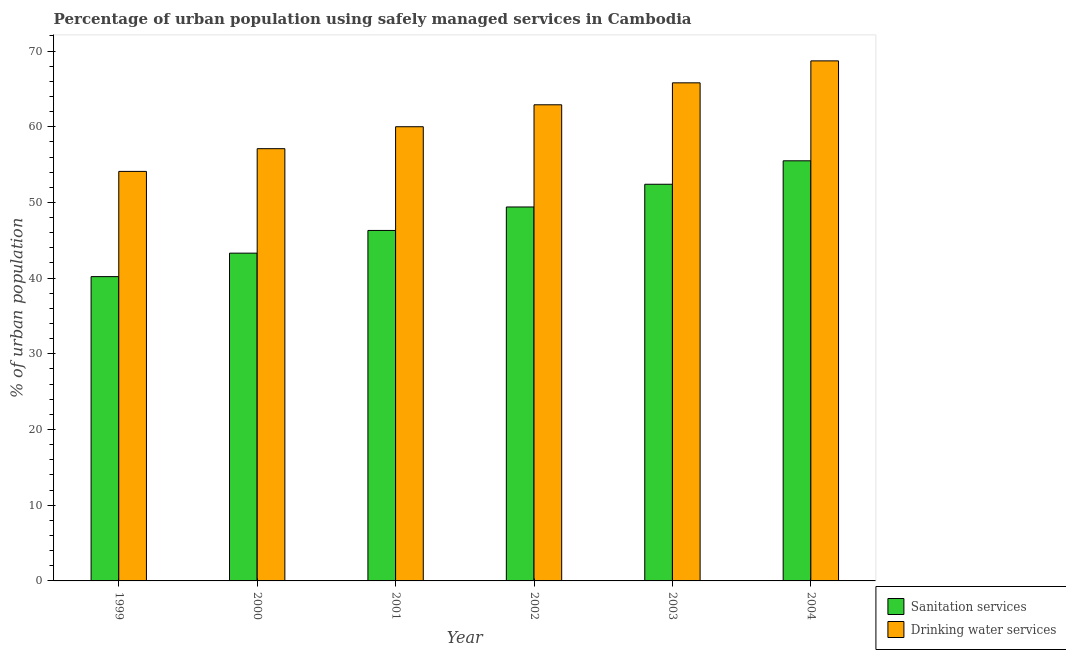How many different coloured bars are there?
Make the answer very short. 2. Are the number of bars per tick equal to the number of legend labels?
Provide a short and direct response. Yes. How many bars are there on the 4th tick from the right?
Your answer should be compact. 2. What is the label of the 4th group of bars from the left?
Your answer should be very brief. 2002. What is the percentage of urban population who used drinking water services in 2000?
Offer a very short reply. 57.1. Across all years, what is the maximum percentage of urban population who used drinking water services?
Provide a short and direct response. 68.7. Across all years, what is the minimum percentage of urban population who used drinking water services?
Keep it short and to the point. 54.1. In which year was the percentage of urban population who used drinking water services maximum?
Provide a short and direct response. 2004. In which year was the percentage of urban population who used drinking water services minimum?
Offer a very short reply. 1999. What is the total percentage of urban population who used drinking water services in the graph?
Make the answer very short. 368.6. What is the difference between the percentage of urban population who used sanitation services in 1999 and that in 2002?
Your answer should be very brief. -9.2. What is the difference between the percentage of urban population who used sanitation services in 2001 and the percentage of urban population who used drinking water services in 1999?
Your response must be concise. 6.1. What is the average percentage of urban population who used sanitation services per year?
Offer a very short reply. 47.85. What is the ratio of the percentage of urban population who used sanitation services in 1999 to that in 2000?
Offer a terse response. 0.93. Is the difference between the percentage of urban population who used sanitation services in 2002 and 2004 greater than the difference between the percentage of urban population who used drinking water services in 2002 and 2004?
Make the answer very short. No. What is the difference between the highest and the second highest percentage of urban population who used sanitation services?
Keep it short and to the point. 3.1. What is the difference between the highest and the lowest percentage of urban population who used drinking water services?
Your answer should be compact. 14.6. In how many years, is the percentage of urban population who used drinking water services greater than the average percentage of urban population who used drinking water services taken over all years?
Your response must be concise. 3. What does the 1st bar from the left in 2004 represents?
Ensure brevity in your answer.  Sanitation services. What does the 1st bar from the right in 2003 represents?
Your response must be concise. Drinking water services. Are all the bars in the graph horizontal?
Your answer should be very brief. No. How many years are there in the graph?
Give a very brief answer. 6. Where does the legend appear in the graph?
Your answer should be compact. Bottom right. What is the title of the graph?
Give a very brief answer. Percentage of urban population using safely managed services in Cambodia. Does "Travel Items" appear as one of the legend labels in the graph?
Your answer should be compact. No. What is the label or title of the X-axis?
Your response must be concise. Year. What is the label or title of the Y-axis?
Provide a short and direct response. % of urban population. What is the % of urban population of Sanitation services in 1999?
Offer a terse response. 40.2. What is the % of urban population of Drinking water services in 1999?
Your answer should be very brief. 54.1. What is the % of urban population in Sanitation services in 2000?
Keep it short and to the point. 43.3. What is the % of urban population of Drinking water services in 2000?
Offer a terse response. 57.1. What is the % of urban population in Sanitation services in 2001?
Make the answer very short. 46.3. What is the % of urban population in Sanitation services in 2002?
Offer a very short reply. 49.4. What is the % of urban population in Drinking water services in 2002?
Give a very brief answer. 62.9. What is the % of urban population in Sanitation services in 2003?
Offer a very short reply. 52.4. What is the % of urban population in Drinking water services in 2003?
Offer a terse response. 65.8. What is the % of urban population of Sanitation services in 2004?
Provide a short and direct response. 55.5. What is the % of urban population of Drinking water services in 2004?
Provide a short and direct response. 68.7. Across all years, what is the maximum % of urban population in Sanitation services?
Your answer should be compact. 55.5. Across all years, what is the maximum % of urban population in Drinking water services?
Offer a very short reply. 68.7. Across all years, what is the minimum % of urban population of Sanitation services?
Ensure brevity in your answer.  40.2. Across all years, what is the minimum % of urban population in Drinking water services?
Your answer should be very brief. 54.1. What is the total % of urban population of Sanitation services in the graph?
Your answer should be very brief. 287.1. What is the total % of urban population in Drinking water services in the graph?
Make the answer very short. 368.6. What is the difference between the % of urban population of Sanitation services in 1999 and that in 2000?
Provide a short and direct response. -3.1. What is the difference between the % of urban population of Drinking water services in 1999 and that in 2000?
Provide a succinct answer. -3. What is the difference between the % of urban population of Sanitation services in 1999 and that in 2001?
Your answer should be compact. -6.1. What is the difference between the % of urban population of Drinking water services in 1999 and that in 2002?
Your answer should be compact. -8.8. What is the difference between the % of urban population of Sanitation services in 1999 and that in 2003?
Offer a very short reply. -12.2. What is the difference between the % of urban population in Sanitation services in 1999 and that in 2004?
Make the answer very short. -15.3. What is the difference between the % of urban population of Drinking water services in 1999 and that in 2004?
Make the answer very short. -14.6. What is the difference between the % of urban population of Sanitation services in 2000 and that in 2001?
Give a very brief answer. -3. What is the difference between the % of urban population of Sanitation services in 2000 and that in 2003?
Your answer should be compact. -9.1. What is the difference between the % of urban population of Drinking water services in 2000 and that in 2003?
Offer a very short reply. -8.7. What is the difference between the % of urban population in Sanitation services in 2001 and that in 2002?
Your answer should be very brief. -3.1. What is the difference between the % of urban population of Drinking water services in 2001 and that in 2002?
Provide a succinct answer. -2.9. What is the difference between the % of urban population in Sanitation services in 2001 and that in 2003?
Your answer should be compact. -6.1. What is the difference between the % of urban population of Drinking water services in 2002 and that in 2003?
Make the answer very short. -2.9. What is the difference between the % of urban population in Sanitation services in 2002 and that in 2004?
Keep it short and to the point. -6.1. What is the difference between the % of urban population of Drinking water services in 2002 and that in 2004?
Provide a short and direct response. -5.8. What is the difference between the % of urban population of Sanitation services in 1999 and the % of urban population of Drinking water services in 2000?
Provide a succinct answer. -16.9. What is the difference between the % of urban population of Sanitation services in 1999 and the % of urban population of Drinking water services in 2001?
Offer a terse response. -19.8. What is the difference between the % of urban population in Sanitation services in 1999 and the % of urban population in Drinking water services in 2002?
Your answer should be compact. -22.7. What is the difference between the % of urban population in Sanitation services in 1999 and the % of urban population in Drinking water services in 2003?
Keep it short and to the point. -25.6. What is the difference between the % of urban population of Sanitation services in 1999 and the % of urban population of Drinking water services in 2004?
Give a very brief answer. -28.5. What is the difference between the % of urban population in Sanitation services in 2000 and the % of urban population in Drinking water services in 2001?
Offer a terse response. -16.7. What is the difference between the % of urban population in Sanitation services in 2000 and the % of urban population in Drinking water services in 2002?
Your answer should be very brief. -19.6. What is the difference between the % of urban population of Sanitation services in 2000 and the % of urban population of Drinking water services in 2003?
Your answer should be very brief. -22.5. What is the difference between the % of urban population of Sanitation services in 2000 and the % of urban population of Drinking water services in 2004?
Keep it short and to the point. -25.4. What is the difference between the % of urban population in Sanitation services in 2001 and the % of urban population in Drinking water services in 2002?
Keep it short and to the point. -16.6. What is the difference between the % of urban population of Sanitation services in 2001 and the % of urban population of Drinking water services in 2003?
Your answer should be very brief. -19.5. What is the difference between the % of urban population in Sanitation services in 2001 and the % of urban population in Drinking water services in 2004?
Make the answer very short. -22.4. What is the difference between the % of urban population of Sanitation services in 2002 and the % of urban population of Drinking water services in 2003?
Keep it short and to the point. -16.4. What is the difference between the % of urban population in Sanitation services in 2002 and the % of urban population in Drinking water services in 2004?
Your answer should be very brief. -19.3. What is the difference between the % of urban population in Sanitation services in 2003 and the % of urban population in Drinking water services in 2004?
Ensure brevity in your answer.  -16.3. What is the average % of urban population in Sanitation services per year?
Your response must be concise. 47.85. What is the average % of urban population of Drinking water services per year?
Your answer should be very brief. 61.43. In the year 1999, what is the difference between the % of urban population of Sanitation services and % of urban population of Drinking water services?
Your response must be concise. -13.9. In the year 2000, what is the difference between the % of urban population in Sanitation services and % of urban population in Drinking water services?
Offer a very short reply. -13.8. In the year 2001, what is the difference between the % of urban population in Sanitation services and % of urban population in Drinking water services?
Keep it short and to the point. -13.7. In the year 2002, what is the difference between the % of urban population in Sanitation services and % of urban population in Drinking water services?
Your answer should be very brief. -13.5. What is the ratio of the % of urban population of Sanitation services in 1999 to that in 2000?
Your response must be concise. 0.93. What is the ratio of the % of urban population in Drinking water services in 1999 to that in 2000?
Your answer should be very brief. 0.95. What is the ratio of the % of urban population in Sanitation services in 1999 to that in 2001?
Your response must be concise. 0.87. What is the ratio of the % of urban population in Drinking water services in 1999 to that in 2001?
Give a very brief answer. 0.9. What is the ratio of the % of urban population of Sanitation services in 1999 to that in 2002?
Provide a short and direct response. 0.81. What is the ratio of the % of urban population of Drinking water services in 1999 to that in 2002?
Offer a very short reply. 0.86. What is the ratio of the % of urban population of Sanitation services in 1999 to that in 2003?
Offer a very short reply. 0.77. What is the ratio of the % of urban population in Drinking water services in 1999 to that in 2003?
Make the answer very short. 0.82. What is the ratio of the % of urban population in Sanitation services in 1999 to that in 2004?
Provide a short and direct response. 0.72. What is the ratio of the % of urban population of Drinking water services in 1999 to that in 2004?
Keep it short and to the point. 0.79. What is the ratio of the % of urban population of Sanitation services in 2000 to that in 2001?
Provide a succinct answer. 0.94. What is the ratio of the % of urban population in Drinking water services in 2000 to that in 2001?
Ensure brevity in your answer.  0.95. What is the ratio of the % of urban population in Sanitation services in 2000 to that in 2002?
Ensure brevity in your answer.  0.88. What is the ratio of the % of urban population in Drinking water services in 2000 to that in 2002?
Offer a terse response. 0.91. What is the ratio of the % of urban population in Sanitation services in 2000 to that in 2003?
Offer a terse response. 0.83. What is the ratio of the % of urban population in Drinking water services in 2000 to that in 2003?
Your answer should be compact. 0.87. What is the ratio of the % of urban population of Sanitation services in 2000 to that in 2004?
Provide a succinct answer. 0.78. What is the ratio of the % of urban population in Drinking water services in 2000 to that in 2004?
Provide a succinct answer. 0.83. What is the ratio of the % of urban population of Sanitation services in 2001 to that in 2002?
Make the answer very short. 0.94. What is the ratio of the % of urban population in Drinking water services in 2001 to that in 2002?
Provide a succinct answer. 0.95. What is the ratio of the % of urban population in Sanitation services in 2001 to that in 2003?
Give a very brief answer. 0.88. What is the ratio of the % of urban population of Drinking water services in 2001 to that in 2003?
Make the answer very short. 0.91. What is the ratio of the % of urban population in Sanitation services in 2001 to that in 2004?
Provide a short and direct response. 0.83. What is the ratio of the % of urban population in Drinking water services in 2001 to that in 2004?
Offer a terse response. 0.87. What is the ratio of the % of urban population in Sanitation services in 2002 to that in 2003?
Ensure brevity in your answer.  0.94. What is the ratio of the % of urban population of Drinking water services in 2002 to that in 2003?
Your answer should be very brief. 0.96. What is the ratio of the % of urban population in Sanitation services in 2002 to that in 2004?
Make the answer very short. 0.89. What is the ratio of the % of urban population of Drinking water services in 2002 to that in 2004?
Offer a terse response. 0.92. What is the ratio of the % of urban population of Sanitation services in 2003 to that in 2004?
Your response must be concise. 0.94. What is the ratio of the % of urban population of Drinking water services in 2003 to that in 2004?
Ensure brevity in your answer.  0.96. What is the difference between the highest and the second highest % of urban population in Sanitation services?
Your answer should be very brief. 3.1. What is the difference between the highest and the second highest % of urban population in Drinking water services?
Provide a short and direct response. 2.9. What is the difference between the highest and the lowest % of urban population in Sanitation services?
Offer a very short reply. 15.3. What is the difference between the highest and the lowest % of urban population of Drinking water services?
Give a very brief answer. 14.6. 